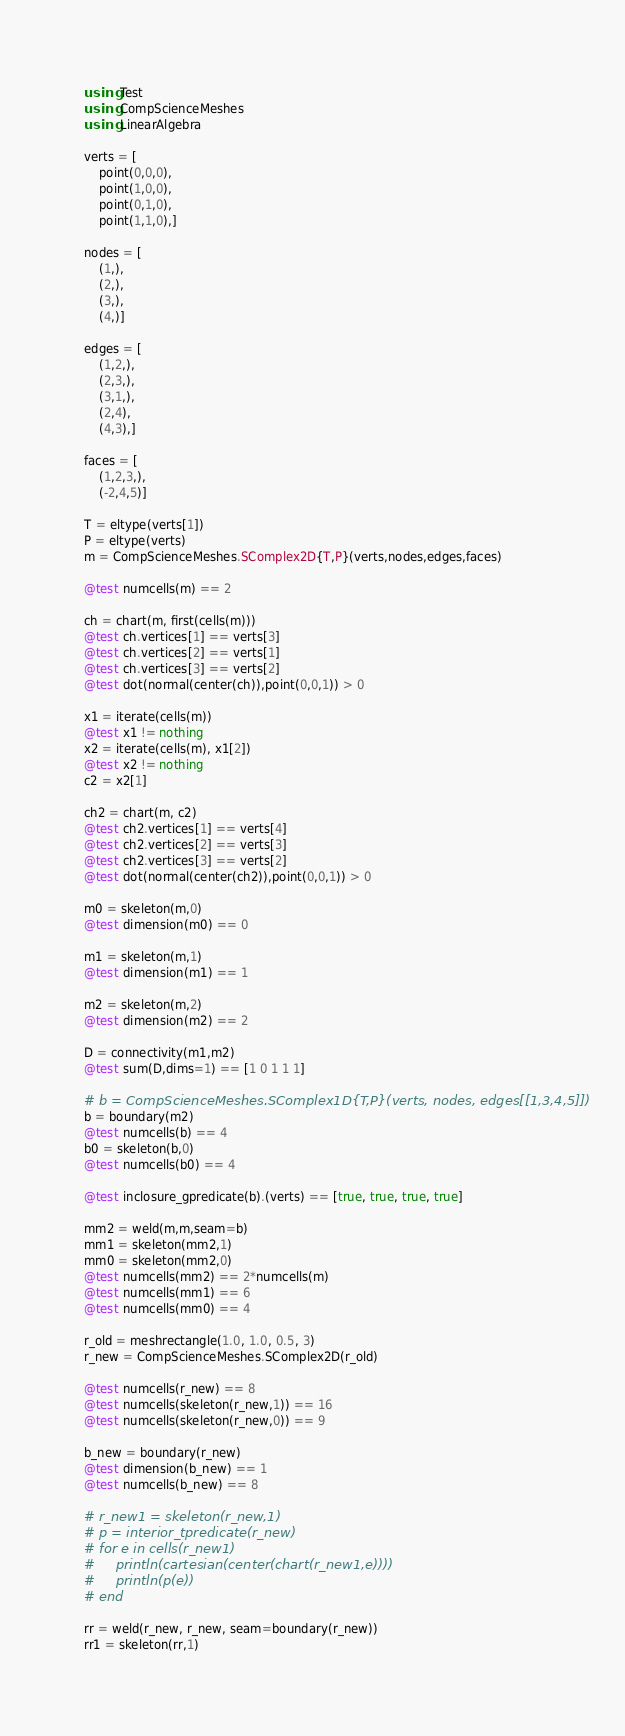Convert code to text. <code><loc_0><loc_0><loc_500><loc_500><_Julia_>using Test
using CompScienceMeshes
using LinearAlgebra

verts = [
    point(0,0,0),
    point(1,0,0),
    point(0,1,0),
    point(1,1,0),]

nodes = [
    (1,),
    (2,),
    (3,),
    (4,)]

edges = [
    (1,2,),
    (2,3,),
    (3,1,),
    (2,4),
    (4,3),]

faces = [
    (1,2,3,),
    (-2,4,5)]

T = eltype(verts[1])
P = eltype(verts)
m = CompScienceMeshes.SComplex2D{T,P}(verts,nodes,edges,faces)

@test numcells(m) == 2

ch = chart(m, first(cells(m)))
@test ch.vertices[1] == verts[3]
@test ch.vertices[2] == verts[1]
@test ch.vertices[3] == verts[2]
@test dot(normal(center(ch)),point(0,0,1)) > 0

x1 = iterate(cells(m))
@test x1 != nothing
x2 = iterate(cells(m), x1[2])
@test x2 != nothing
c2 = x2[1]

ch2 = chart(m, c2)
@test ch2.vertices[1] == verts[4]
@test ch2.vertices[2] == verts[3]
@test ch2.vertices[3] == verts[2]
@test dot(normal(center(ch2)),point(0,0,1)) > 0

m0 = skeleton(m,0)
@test dimension(m0) == 0

m1 = skeleton(m,1)
@test dimension(m1) == 1

m2 = skeleton(m,2)
@test dimension(m2) == 2

D = connectivity(m1,m2)
@test sum(D,dims=1) == [1 0 1 1 1]

# b = CompScienceMeshes.SComplex1D{T,P}(verts, nodes, edges[[1,3,4,5]])
b = boundary(m2)
@test numcells(b) == 4
b0 = skeleton(b,0)
@test numcells(b0) == 4

@test inclosure_gpredicate(b).(verts) == [true, true, true, true]

mm2 = weld(m,m,seam=b)
mm1 = skeleton(mm2,1)
mm0 = skeleton(mm2,0)
@test numcells(mm2) == 2*numcells(m)
@test numcells(mm1) == 6
@test numcells(mm0) == 4

r_old = meshrectangle(1.0, 1.0, 0.5, 3)
r_new = CompScienceMeshes.SComplex2D(r_old)

@test numcells(r_new) == 8
@test numcells(skeleton(r_new,1)) == 16
@test numcells(skeleton(r_new,0)) == 9

b_new = boundary(r_new)
@test dimension(b_new) == 1
@test numcells(b_new) == 8

# r_new1 = skeleton(r_new,1)
# p = interior_tpredicate(r_new)
# for e in cells(r_new1)
#     println(cartesian(center(chart(r_new1,e))))
#     println(p(e))
# end

rr = weld(r_new, r_new, seam=boundary(r_new))
rr1 = skeleton(rr,1)</code> 